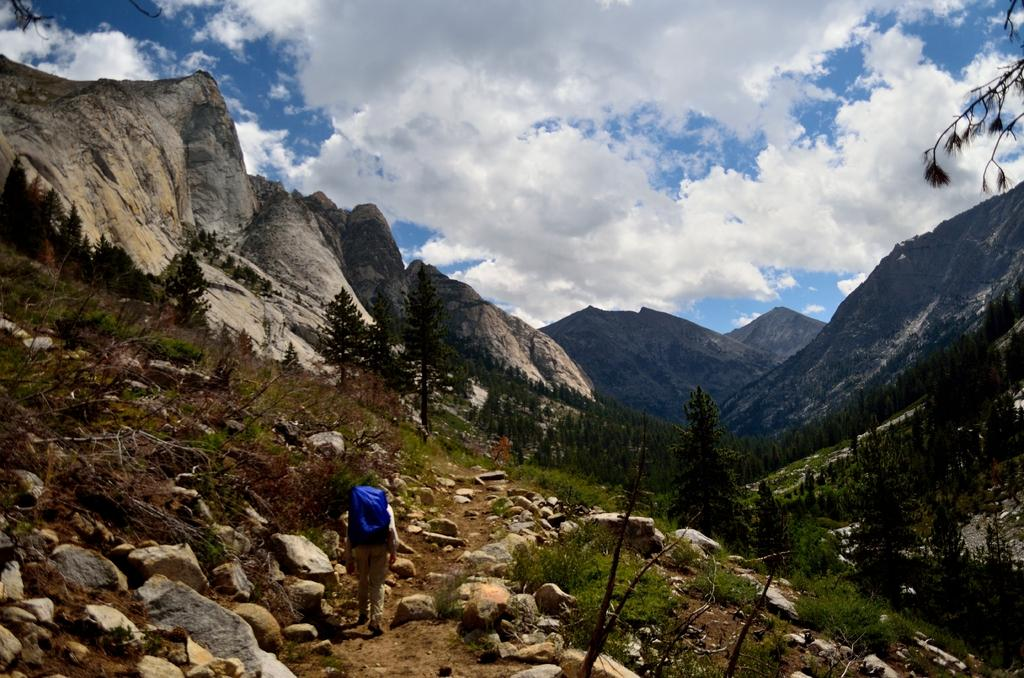Who or what is present in the image? There is a person in the image. What is the person wearing? The person is wearing a bag. What is the person doing in the image? The person is walking on a path. What can be seen in the background of the image? There are rocks, trees, and mountains in the background of the image. How would you describe the sky in the image? The sky is blue and cloudy. Can you see any celery growing near the person in the image? There is no celery visible in the image. Is the person wearing a veil in the image? The person is not wearing a veil in the image; they are wearing a bag. 